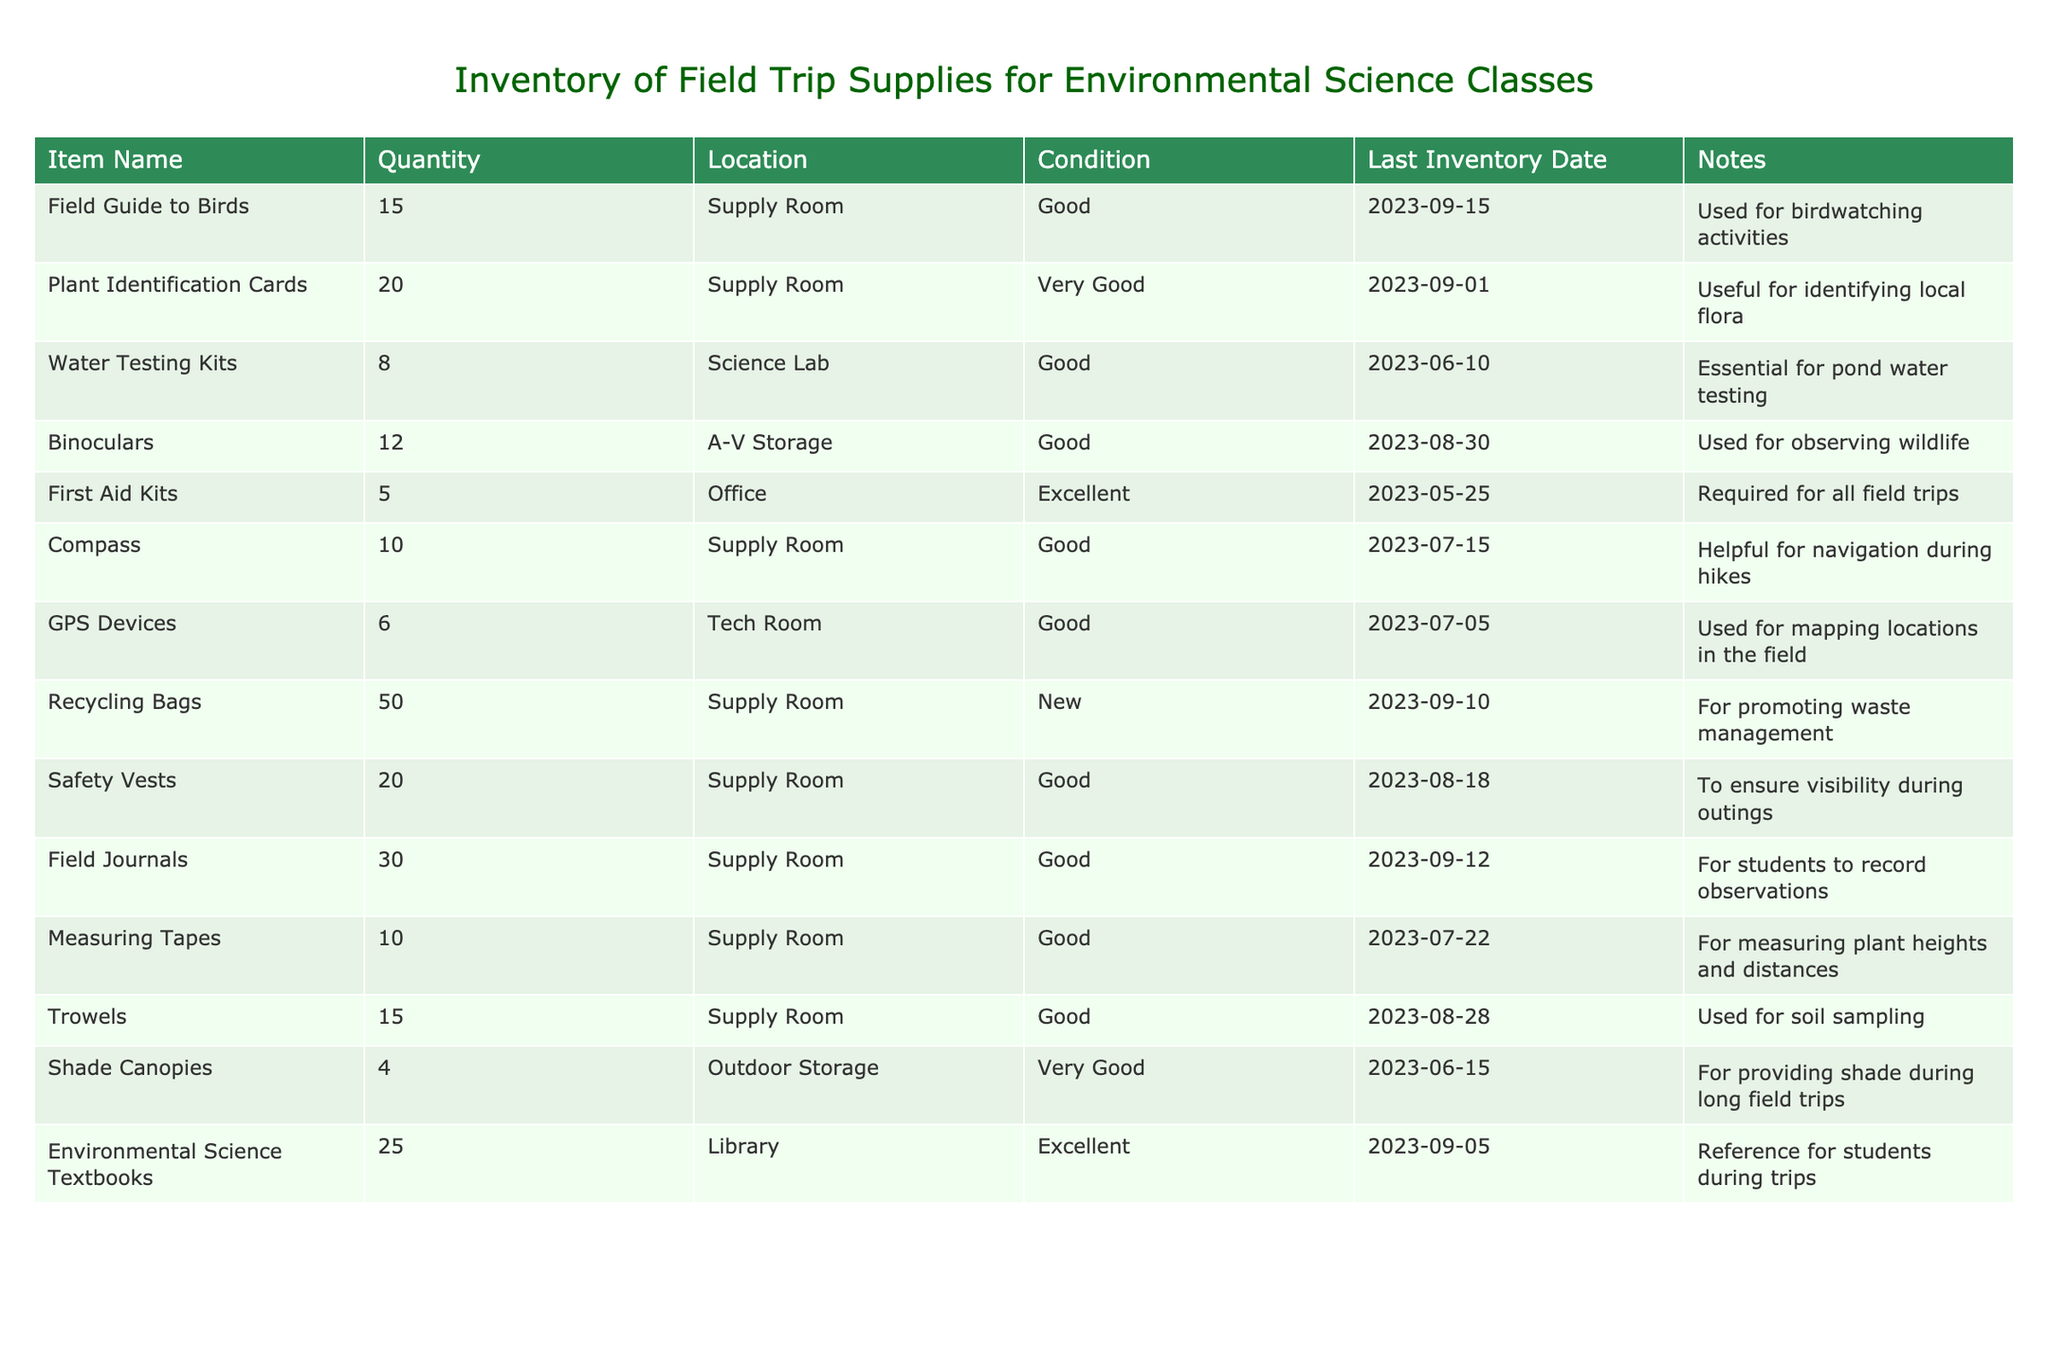What is the condition of the Field Guide to Birds? The table lists the condition for the Field Guide to Birds as 'Good' in the Condition column.
Answer: Good How many Water Testing Kits are available? The Quantity column shows that there are 8 Water Testing Kits available.
Answer: 8 Is there a Safety Vest in 'Excellent' condition? By examining the Condition column, all listed Safety Vests are in 'Good' condition, which means there are no Safety Vests in 'Excellent' condition.
Answer: No What is the total quantity of Plant Identification Cards and Field Journals combined? The Quantity of Plant Identification Cards is 20 and Field Journals is 30. Adding these gives 20 + 30 = 50.
Answer: 50 How many total items are there listed in the inventory? Counting the data rows in the table includes items such as Field Guide to Birds, Plant Identification Cards, and more up to Environmental Science Textbooks, totalizing 12 distinct items.
Answer: 12 Which item has the longest time since the last inventory check? The item with the Last Inventory Date of 2023-06-10 is the Water Testing Kits, indicating this is the longest since their last check.
Answer: Water Testing Kits How many more Recycling Bags are there than First Aid Kits? There are 50 Recycling Bags and 5 First Aid Kits. The difference is calculated as 50 - 5 = 45.
Answer: 45 What percentage of the items are currently in 'Very Good' condition? Noticing that out of 12 items, there are 2 items (Shade Canopies and Plant Identification Cards) in 'Very Good' condition. The percentage is calculated as (2/12) * 100 = 16.67%.
Answer: 16.67% Which item located in the Supply Room has the highest quantity? In reviewing the items in the Supply Room, the Recycling Bags are listed at a quantity of 50, which is the highest among Supply Room items.
Answer: Recycling Bags What are the notes for the GPS Devices? The table indicates that the notes for the GPS Devices mention they are 'Used for mapping locations in the field'.
Answer: Used for mapping locations in the field 